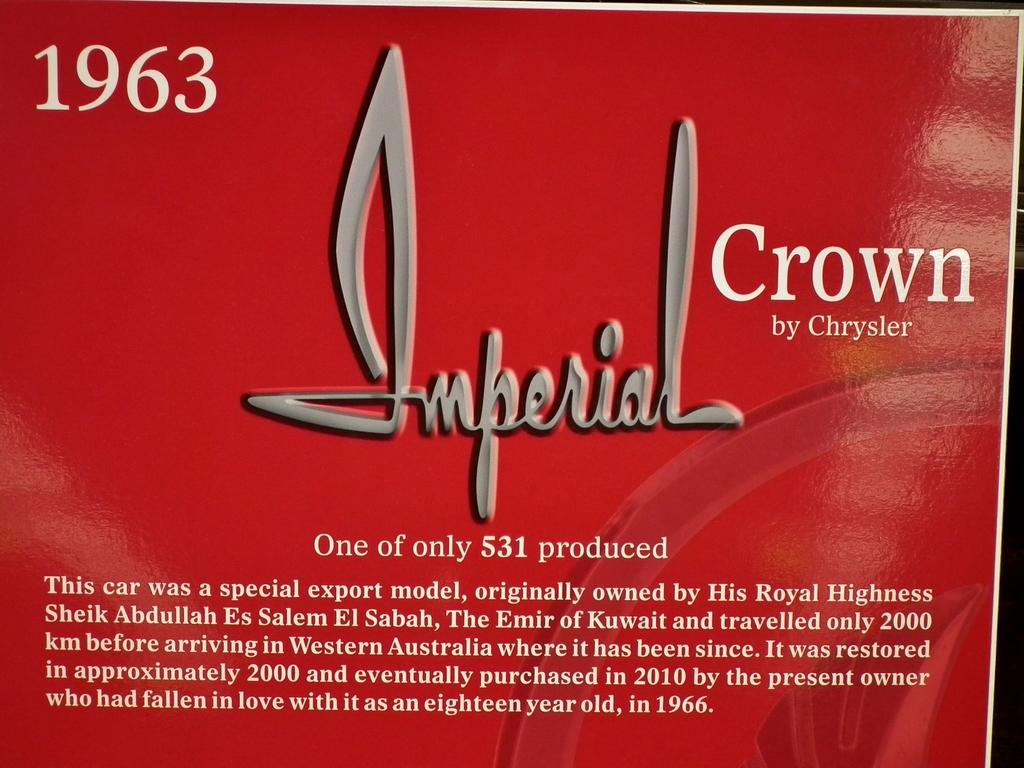Provide a one-sentence caption for the provided image. a poster for Imperial Crown by Chrysler in 1963. 